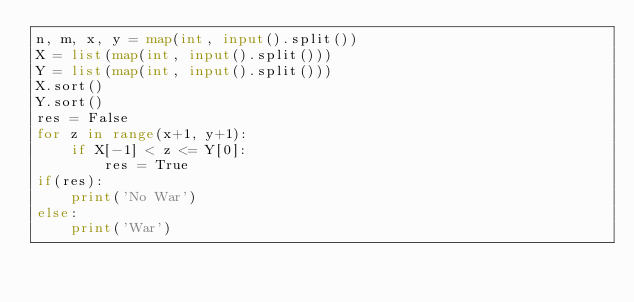Convert code to text. <code><loc_0><loc_0><loc_500><loc_500><_Python_>n, m, x, y = map(int, input().split())
X = list(map(int, input().split()))
Y = list(map(int, input().split()))
X.sort()
Y.sort()
res = False
for z in range(x+1, y+1):
    if X[-1] < z <= Y[0]:
        res = True
if(res):
    print('No War')
else:
    print('War')

</code> 